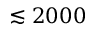Convert formula to latex. <formula><loc_0><loc_0><loc_500><loc_500>\lesssim 2 0 0 0</formula> 